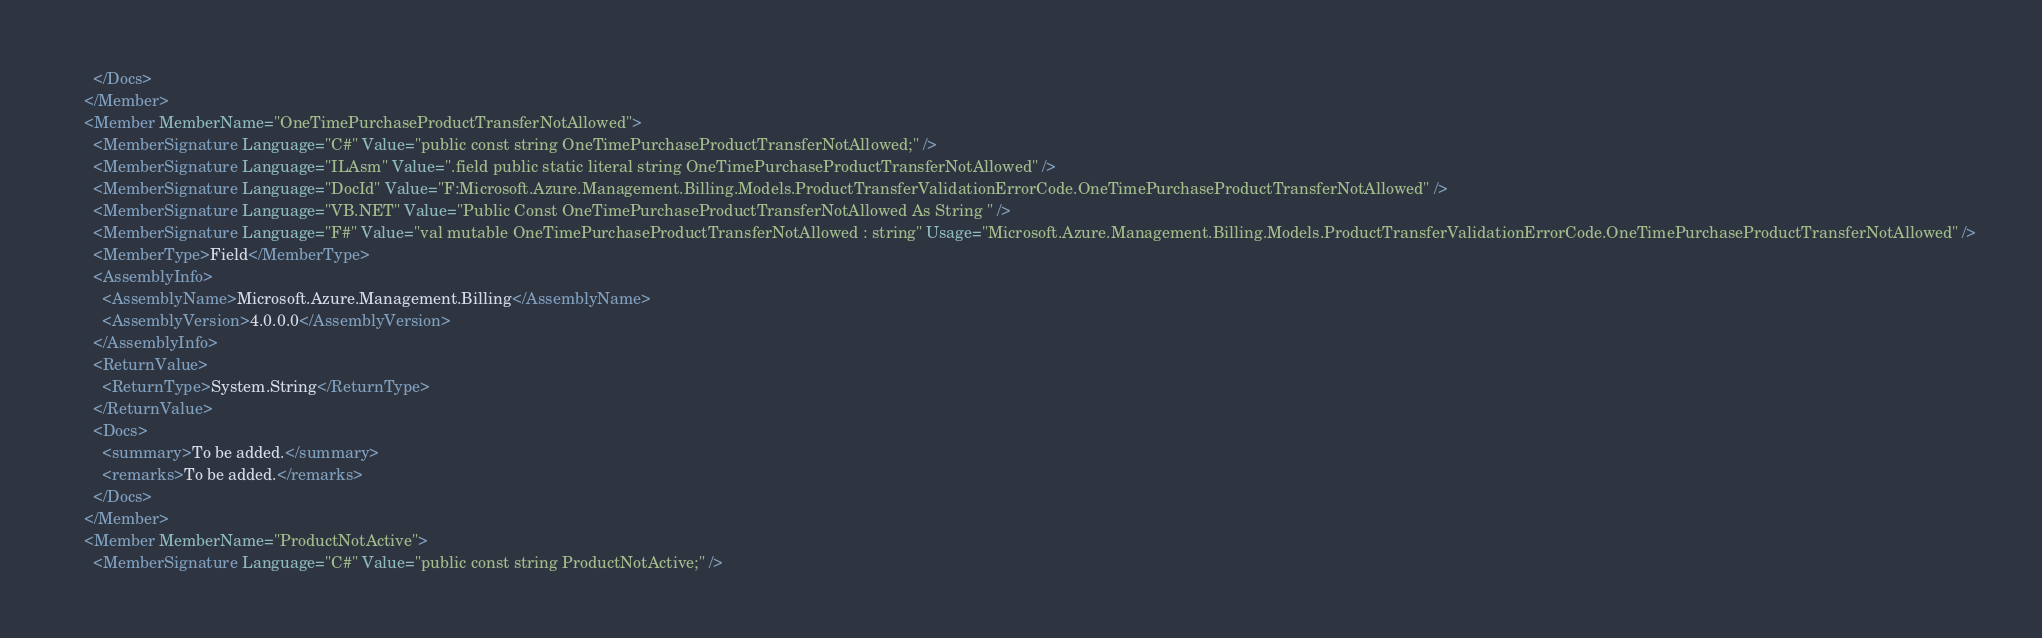Convert code to text. <code><loc_0><loc_0><loc_500><loc_500><_XML_>      </Docs>
    </Member>
    <Member MemberName="OneTimePurchaseProductTransferNotAllowed">
      <MemberSignature Language="C#" Value="public const string OneTimePurchaseProductTransferNotAllowed;" />
      <MemberSignature Language="ILAsm" Value=".field public static literal string OneTimePurchaseProductTransferNotAllowed" />
      <MemberSignature Language="DocId" Value="F:Microsoft.Azure.Management.Billing.Models.ProductTransferValidationErrorCode.OneTimePurchaseProductTransferNotAllowed" />
      <MemberSignature Language="VB.NET" Value="Public Const OneTimePurchaseProductTransferNotAllowed As String " />
      <MemberSignature Language="F#" Value="val mutable OneTimePurchaseProductTransferNotAllowed : string" Usage="Microsoft.Azure.Management.Billing.Models.ProductTransferValidationErrorCode.OneTimePurchaseProductTransferNotAllowed" />
      <MemberType>Field</MemberType>
      <AssemblyInfo>
        <AssemblyName>Microsoft.Azure.Management.Billing</AssemblyName>
        <AssemblyVersion>4.0.0.0</AssemblyVersion>
      </AssemblyInfo>
      <ReturnValue>
        <ReturnType>System.String</ReturnType>
      </ReturnValue>
      <Docs>
        <summary>To be added.</summary>
        <remarks>To be added.</remarks>
      </Docs>
    </Member>
    <Member MemberName="ProductNotActive">
      <MemberSignature Language="C#" Value="public const string ProductNotActive;" /></code> 